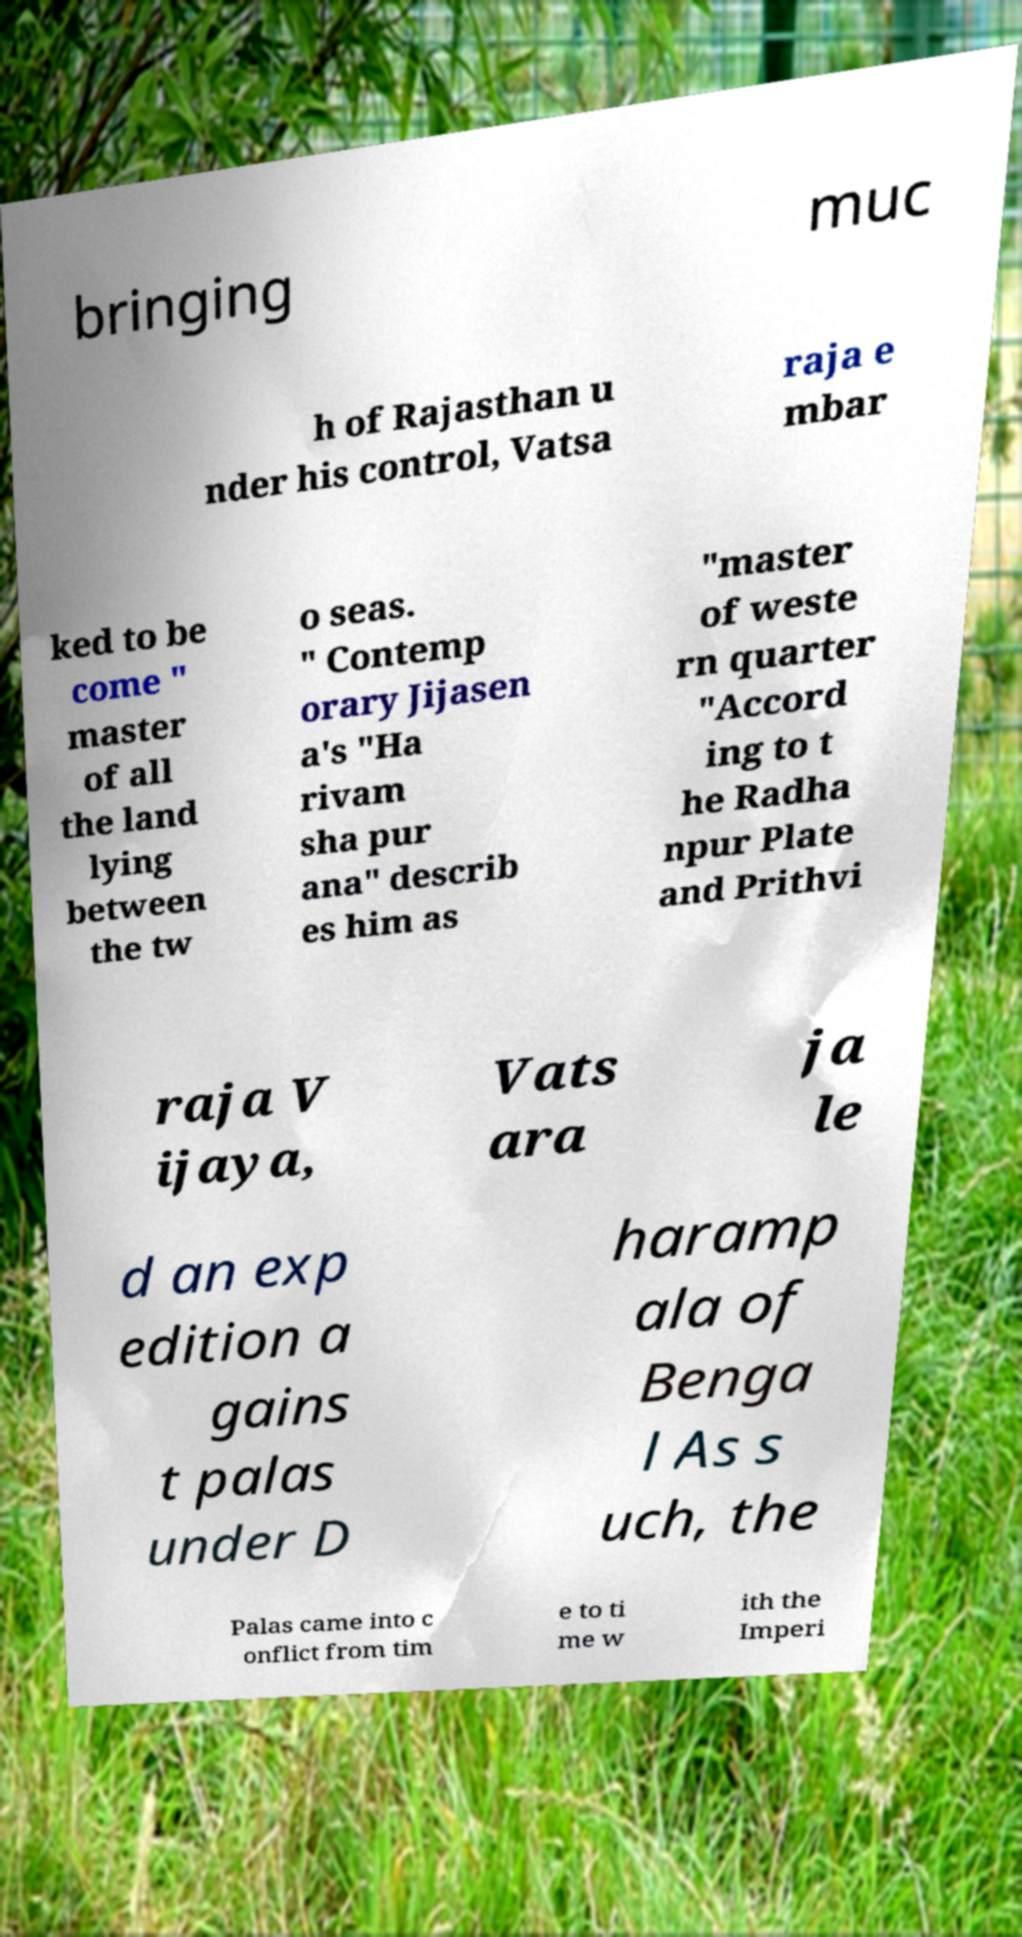I need the written content from this picture converted into text. Can you do that? bringing muc h of Rajasthan u nder his control, Vatsa raja e mbar ked to be come " master of all the land lying between the tw o seas. " Contemp orary Jijasen a's "Ha rivam sha pur ana" describ es him as "master of weste rn quarter "Accord ing to t he Radha npur Plate and Prithvi raja V ijaya, Vats ara ja le d an exp edition a gains t palas under D haramp ala of Benga l As s uch, the Palas came into c onflict from tim e to ti me w ith the Imperi 